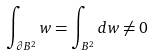Convert formula to latex. <formula><loc_0><loc_0><loc_500><loc_500>\int _ { \partial B ^ { 2 } } w = \int _ { B ^ { 2 } } d w \neq 0</formula> 